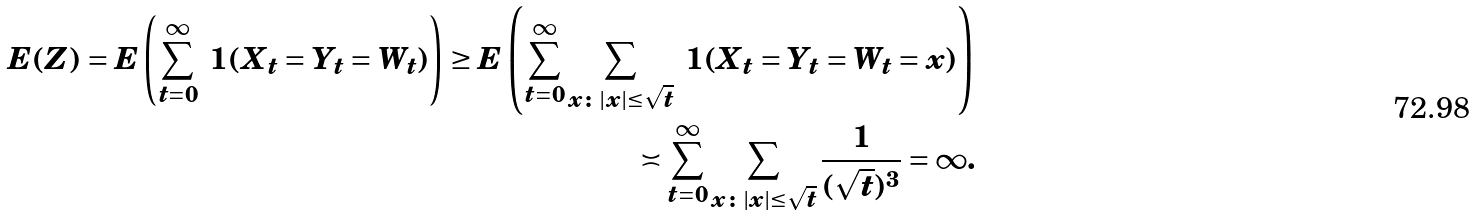Convert formula to latex. <formula><loc_0><loc_0><loc_500><loc_500>E ( Z ) = E \left ( \sum _ { t = 0 } ^ { \infty } \ 1 ( X _ { t } = Y _ { t } = W _ { t } ) \right ) \geq E \left ( \sum _ { t = 0 } ^ { \infty } \sum _ { x \colon | x | \leq \sqrt { t } } \ 1 ( X _ { t } = Y _ { t } = W _ { t } = x ) \right ) \\ \asymp \sum _ { t = 0 } ^ { \infty } \sum _ { x \colon | x | \leq \sqrt { t } } \frac { 1 } { ( \sqrt { t } ) ^ { 3 } } = \infty .</formula> 